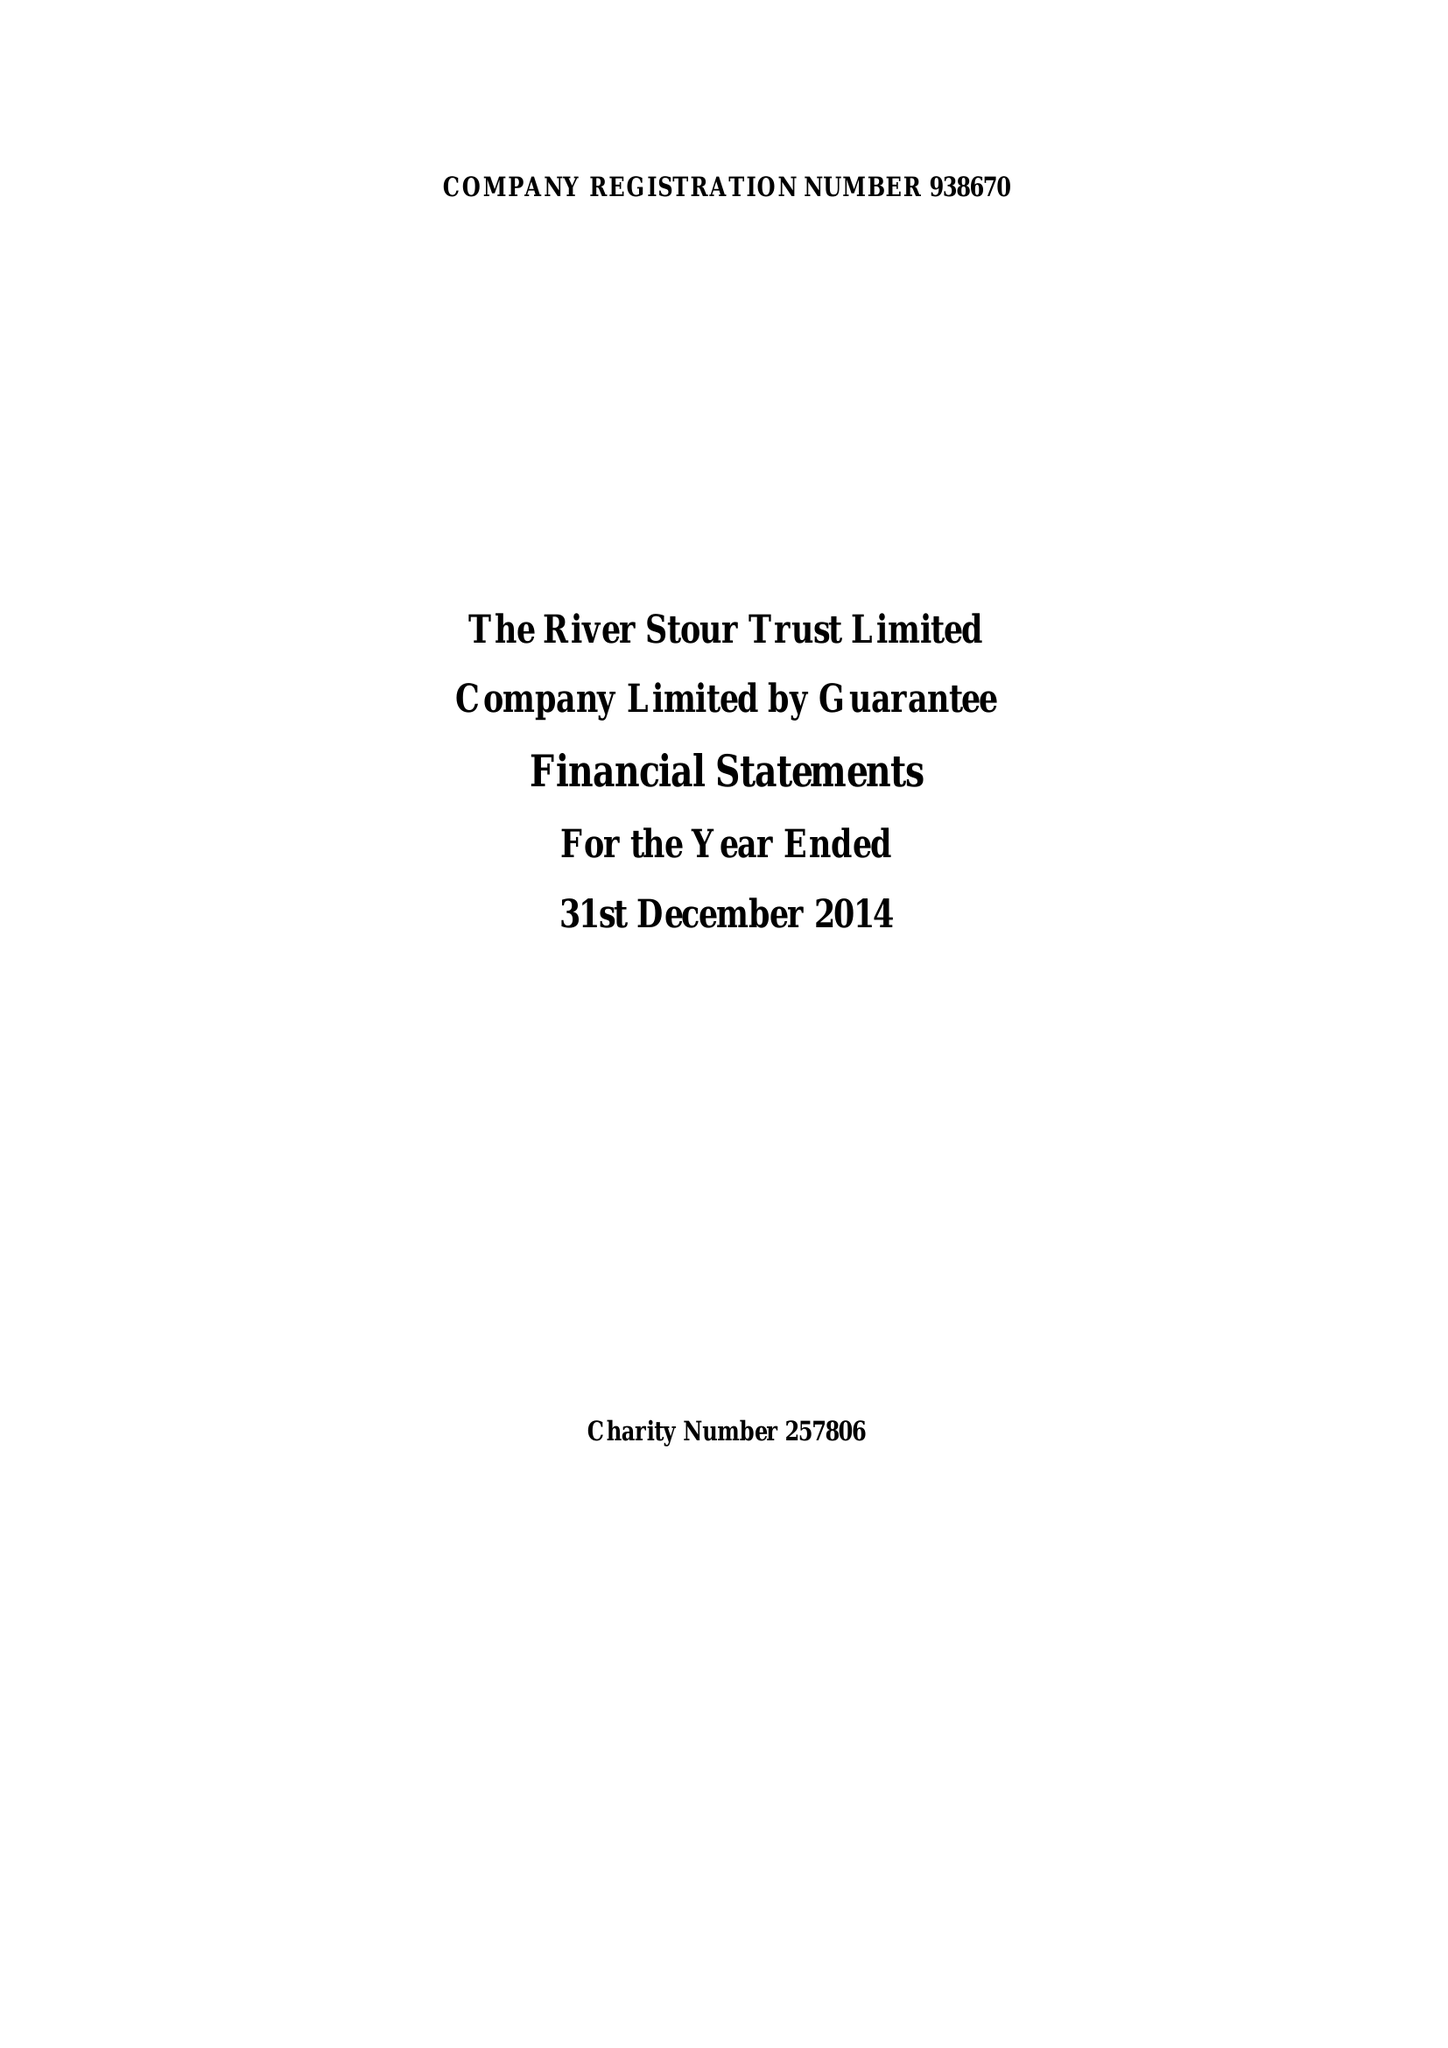What is the value for the charity_name?
Answer the question using a single word or phrase. The River Stour Trust Ltd. 